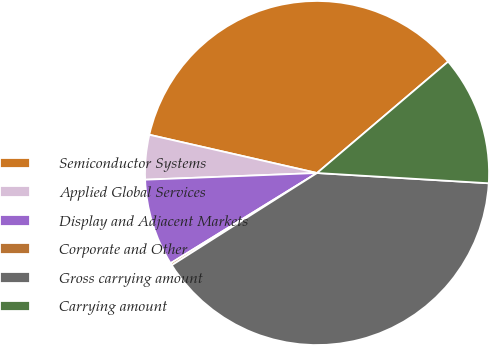<chart> <loc_0><loc_0><loc_500><loc_500><pie_chart><fcel>Semiconductor Systems<fcel>Applied Global Services<fcel>Display and Adjacent Markets<fcel>Corporate and Other<fcel>Gross carrying amount<fcel>Carrying amount<nl><fcel>35.22%<fcel>4.19%<fcel>8.17%<fcel>0.21%<fcel>40.05%<fcel>12.16%<nl></chart> 